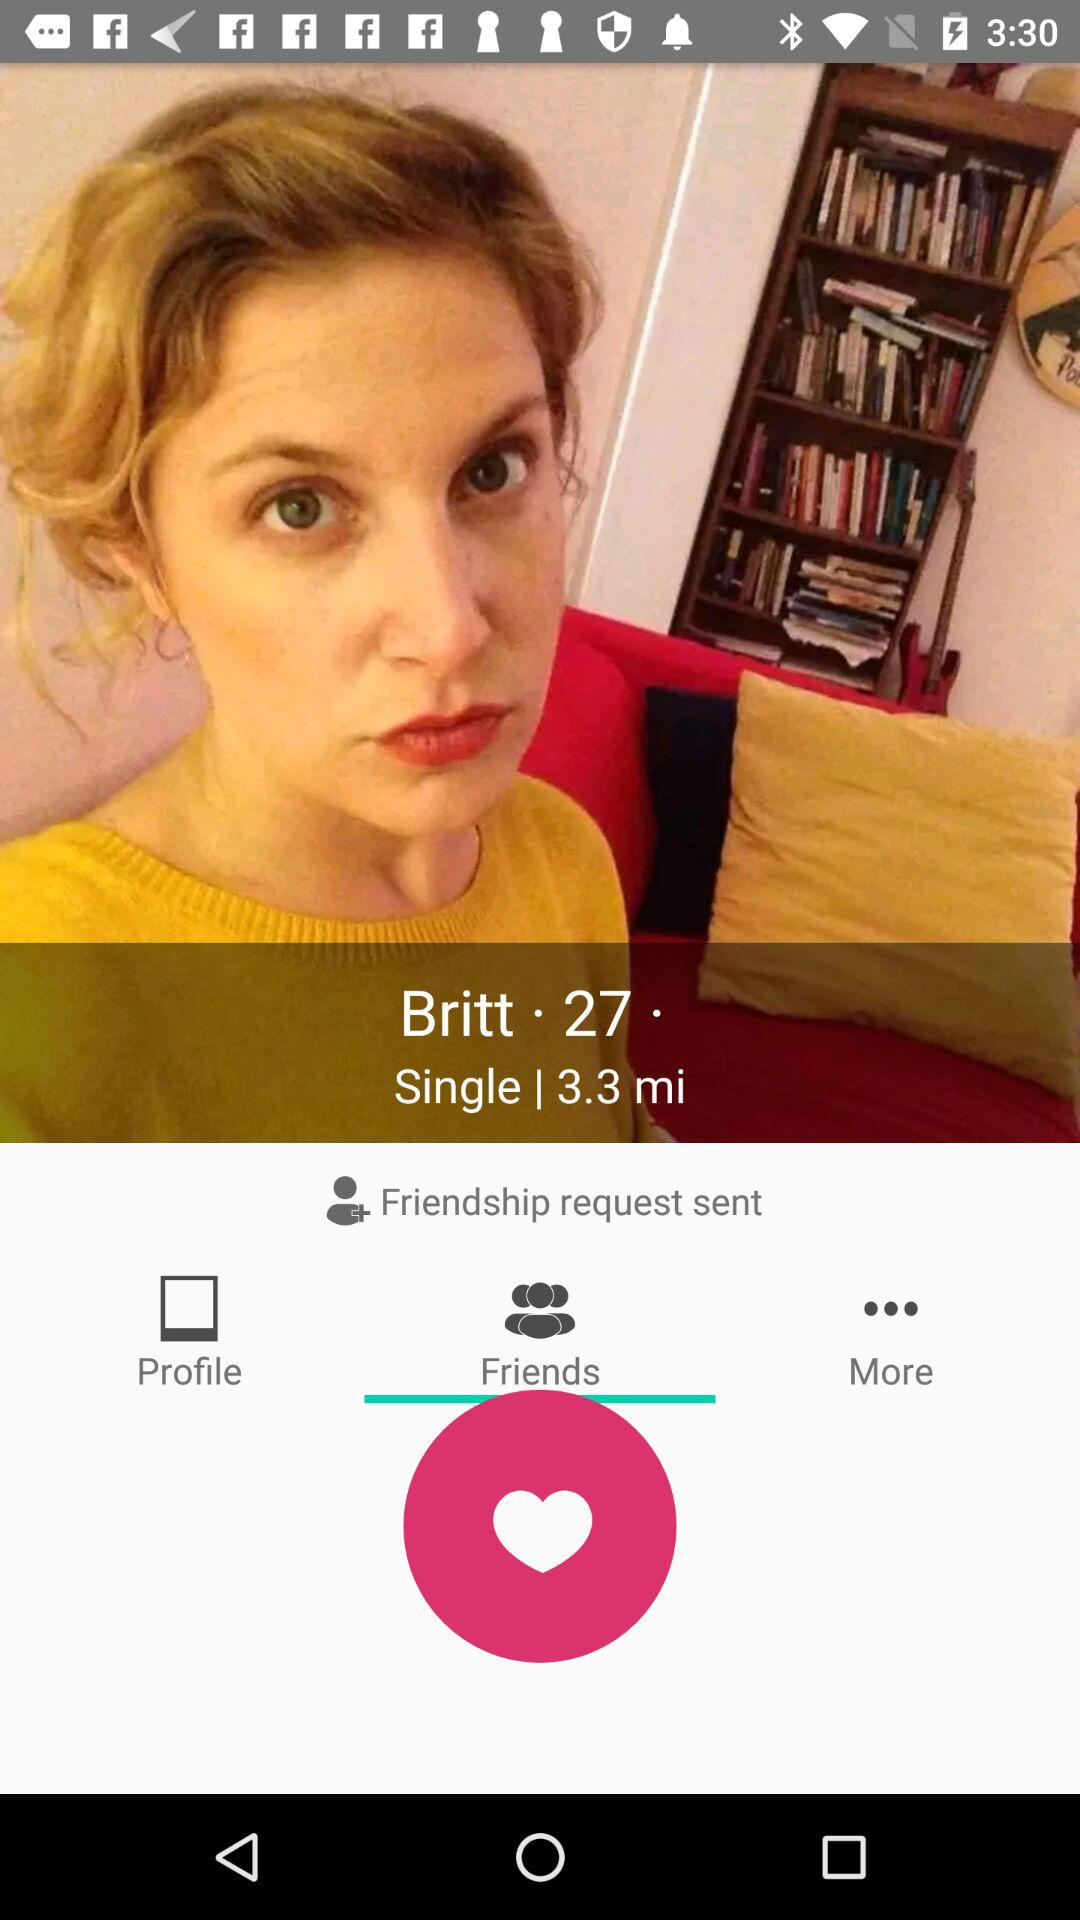How far is Britt's location from my location? Britt's location is 3.3 miles away from your location. 